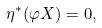<formula> <loc_0><loc_0><loc_500><loc_500>\eta ^ { \ast } ( \varphi X ) = 0 ,</formula> 